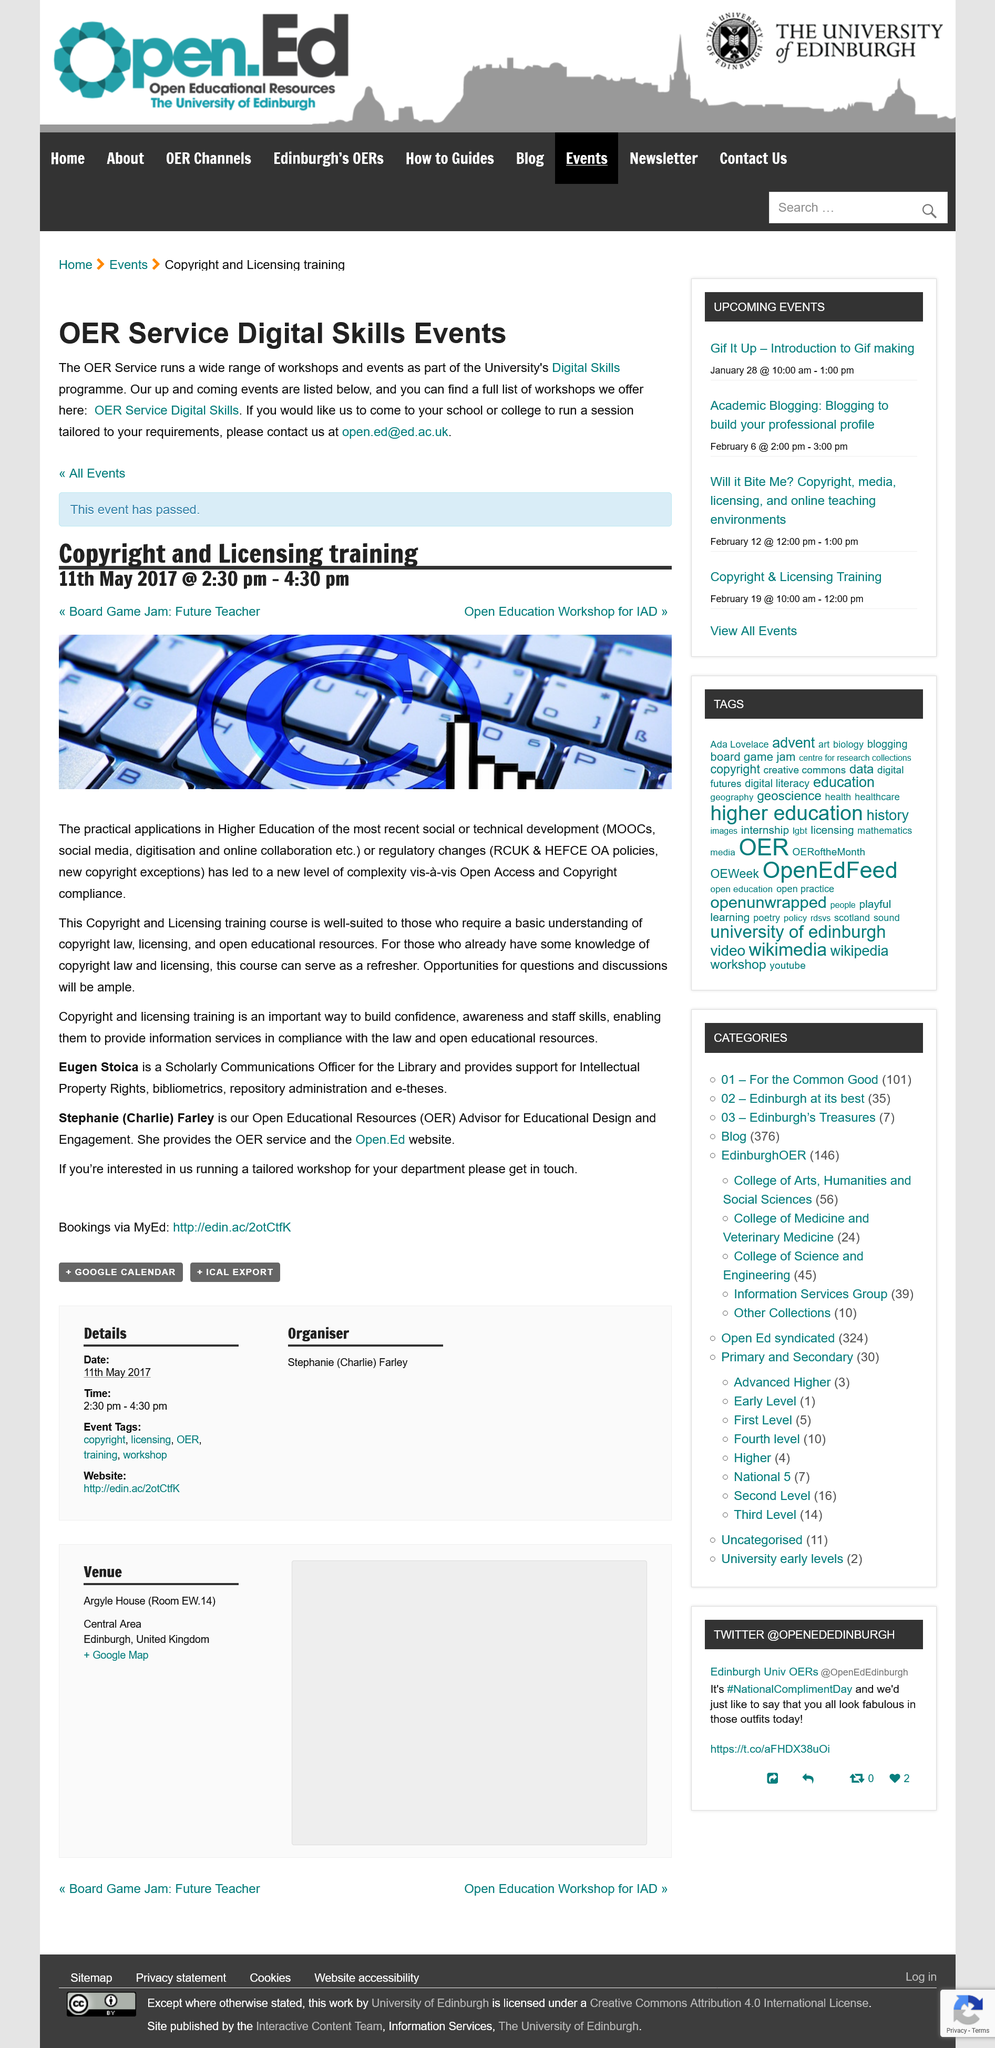Indicate a few pertinent items in this graphic. The event was a Copyright and Licensing training, which focused on providing attendees with knowledge and skills regarding these topics. The event took place on May 11th, 2017. The event lasted for a duration of 2 hours. 